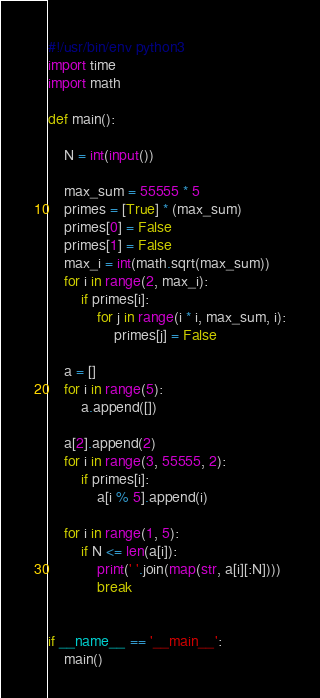<code> <loc_0><loc_0><loc_500><loc_500><_Python_>#!/usr/bin/env python3
import time
import math

def main():

    N = int(input())

    max_sum = 55555 * 5
    primes = [True] * (max_sum)
    primes[0] = False
    primes[1] = False
    max_i = int(math.sqrt(max_sum))
    for i in range(2, max_i):
        if primes[i]:
            for j in range(i * i, max_sum, i):
                primes[j] = False

    a = []
    for i in range(5):
        a.append([])

    a[2].append(2)
    for i in range(3, 55555, 2):
        if primes[i]:
            a[i % 5].append(i)

    for i in range(1, 5):
        if N <= len(a[i]):
            print(' '.join(map(str, a[i][:N])))
            break


if __name__ == '__main__':
    main()

</code> 